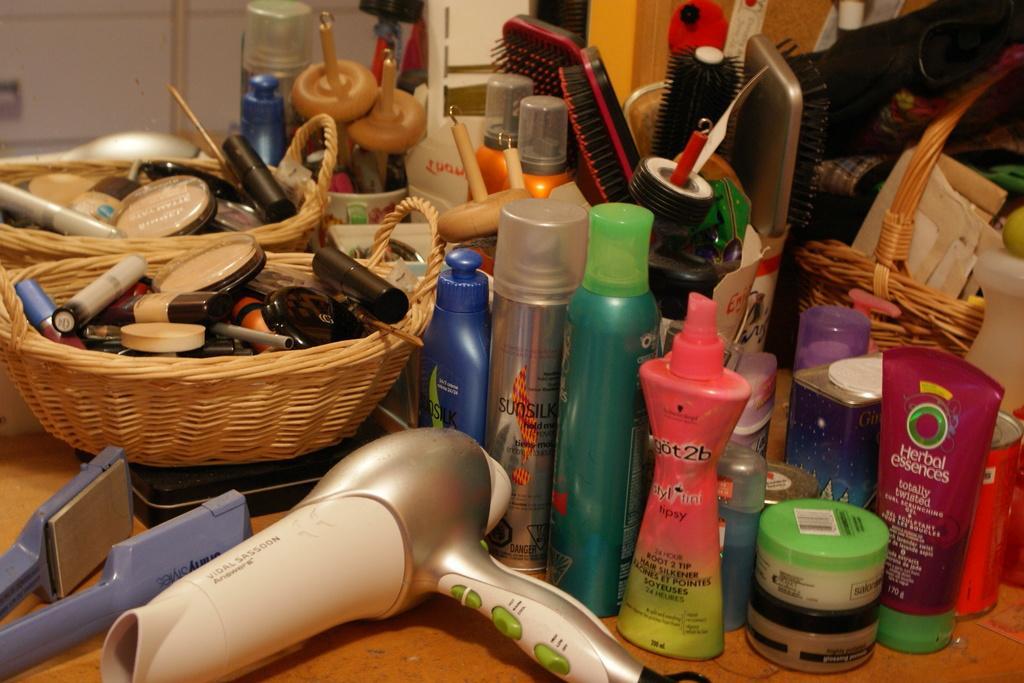<image>
Summarize the visual content of the image. Assorted hair care products including one made by Herbal Essences 